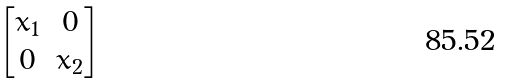<formula> <loc_0><loc_0><loc_500><loc_500>\begin{bmatrix} x _ { 1 } & 0 \\ 0 & x _ { 2 } \end{bmatrix}</formula> 